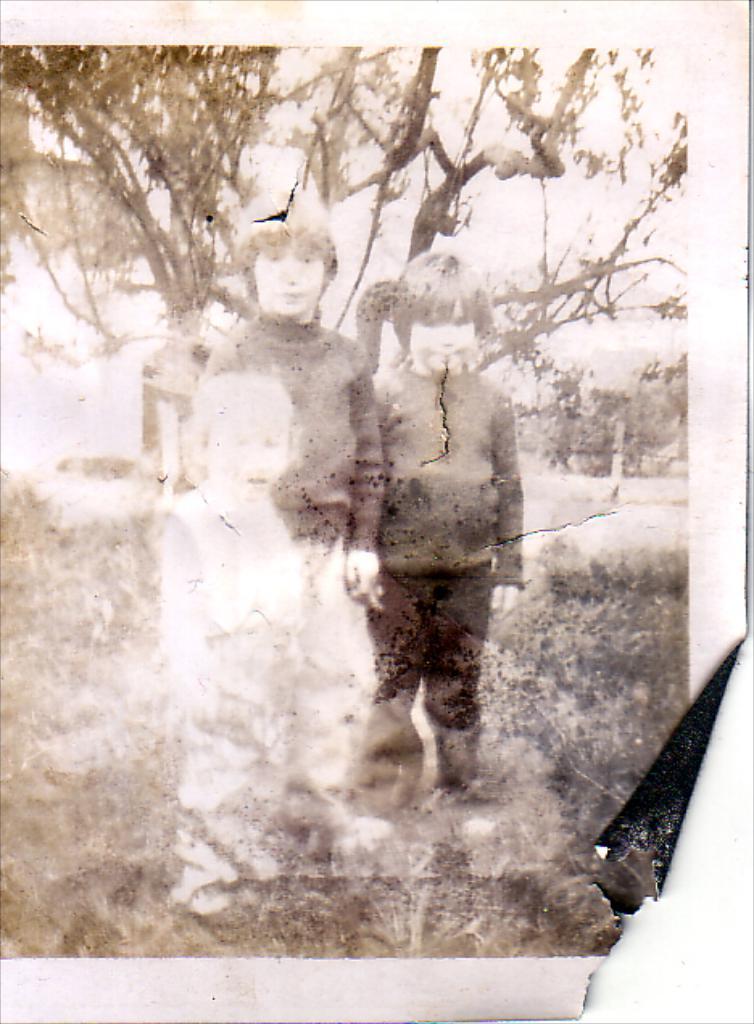Can you describe this image briefly? In this image, we can see a photograph. Here we can see three kids are standing. Here there are few plants. Background we can see trees. 